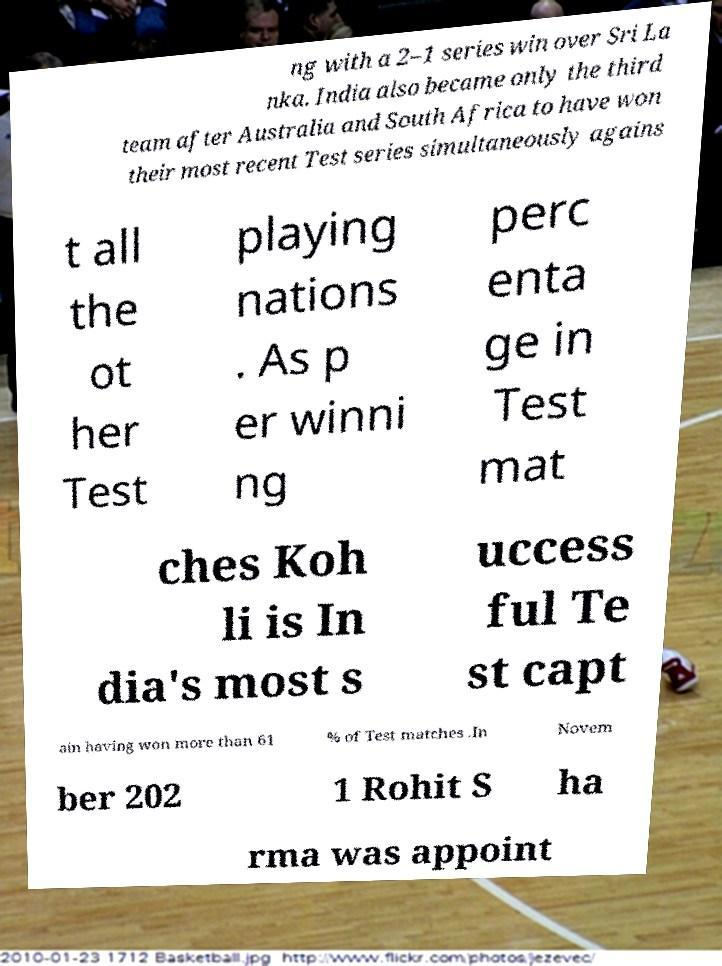Could you extract and type out the text from this image? ng with a 2–1 series win over Sri La nka. India also became only the third team after Australia and South Africa to have won their most recent Test series simultaneously agains t all the ot her Test playing nations . As p er winni ng perc enta ge in Test mat ches Koh li is In dia's most s uccess ful Te st capt ain having won more than 61 % of Test matches .In Novem ber 202 1 Rohit S ha rma was appoint 